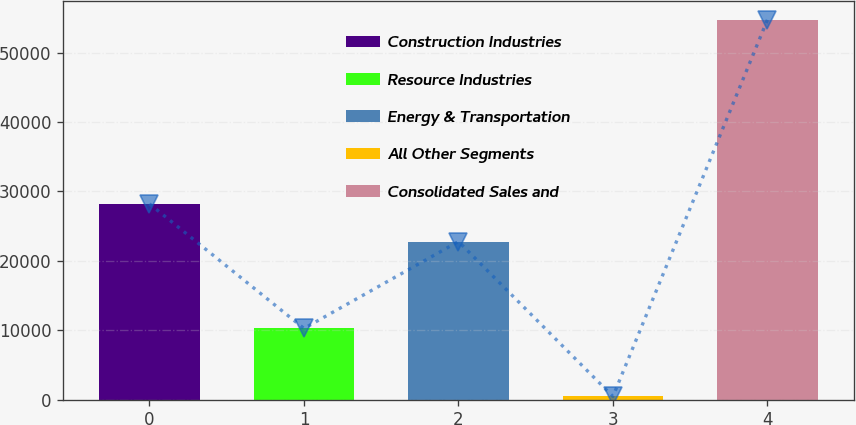<chart> <loc_0><loc_0><loc_500><loc_500><bar_chart><fcel>Construction Industries<fcel>Resource Industries<fcel>Energy & Transportation<fcel>All Other Segments<fcel>Consolidated Sales and<nl><fcel>28209<fcel>10270<fcel>22785<fcel>482<fcel>54722<nl></chart> 